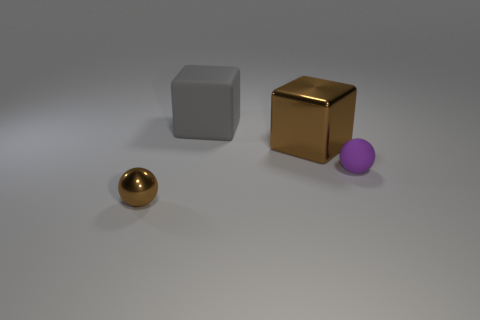What number of small brown spheres are made of the same material as the big brown thing?
Offer a very short reply. 1. There is a big thing in front of the large rubber object; what number of tiny things are left of it?
Give a very brief answer. 1. What shape is the tiny object in front of the tiny thing right of the tiny object left of the big gray rubber thing?
Offer a terse response. Sphere. What is the size of the metal sphere that is the same color as the large shiny object?
Your answer should be compact. Small. What number of things are big matte things or red matte cylinders?
Offer a terse response. 1. What color is the shiny sphere that is the same size as the purple rubber object?
Offer a terse response. Brown. Do the large gray object and the brown thing that is on the right side of the large matte block have the same shape?
Your response must be concise. Yes. What number of things are either objects in front of the purple matte ball or tiny spheres to the left of the big brown shiny block?
Give a very brief answer. 1. What is the shape of the other object that is the same color as the big metal object?
Give a very brief answer. Sphere. What shape is the brown thing to the left of the gray cube?
Your response must be concise. Sphere. 